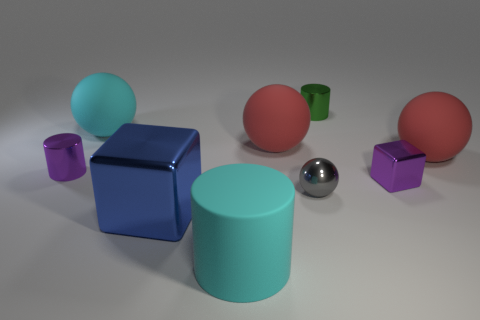Subtract all gray balls. How many balls are left? 3 Subtract all small shiny spheres. How many spheres are left? 3 Subtract all spheres. How many objects are left? 5 Subtract all gray shiny cylinders. Subtract all tiny blocks. How many objects are left? 8 Add 7 tiny cubes. How many tiny cubes are left? 8 Add 5 big cyan things. How many big cyan things exist? 7 Subtract 0 yellow cylinders. How many objects are left? 9 Subtract 1 cubes. How many cubes are left? 1 Subtract all green cylinders. Subtract all green cubes. How many cylinders are left? 2 Subtract all blue cylinders. How many purple cubes are left? 1 